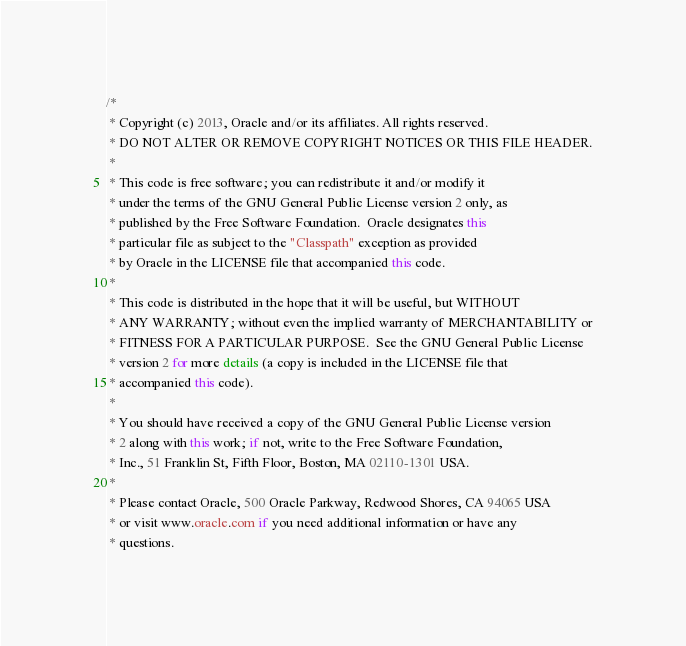<code> <loc_0><loc_0><loc_500><loc_500><_Java_>/*
 * Copyright (c) 2013, Oracle and/or its affiliates. All rights reserved.
 * DO NOT ALTER OR REMOVE COPYRIGHT NOTICES OR THIS FILE HEADER.
 *
 * This code is free software; you can redistribute it and/or modify it
 * under the terms of the GNU General Public License version 2 only, as
 * published by the Free Software Foundation.  Oracle designates this
 * particular file as subject to the "Classpath" exception as provided
 * by Oracle in the LICENSE file that accompanied this code.
 *
 * This code is distributed in the hope that it will be useful, but WITHOUT
 * ANY WARRANTY; without even the implied warranty of MERCHANTABILITY or
 * FITNESS FOR A PARTICULAR PURPOSE.  See the GNU General Public License
 * version 2 for more details (a copy is included in the LICENSE file that
 * accompanied this code).
 *
 * You should have received a copy of the GNU General Public License version
 * 2 along with this work; if not, write to the Free Software Foundation,
 * Inc., 51 Franklin St, Fifth Floor, Boston, MA 02110-1301 USA.
 *
 * Please contact Oracle, 500 Oracle Parkway, Redwood Shores, CA 94065 USA
 * or visit www.oracle.com if you need additional information or have any
 * questions.</code> 